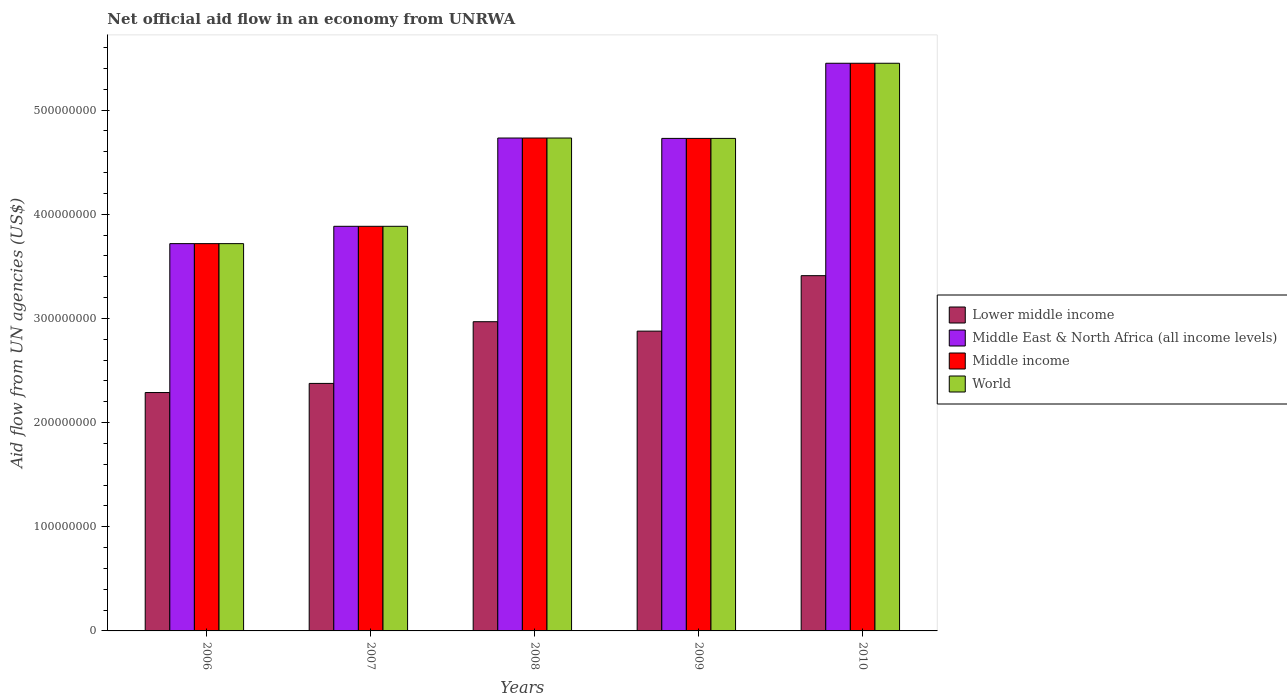Are the number of bars per tick equal to the number of legend labels?
Offer a terse response. Yes. Are the number of bars on each tick of the X-axis equal?
Give a very brief answer. Yes. How many bars are there on the 4th tick from the right?
Make the answer very short. 4. In how many cases, is the number of bars for a given year not equal to the number of legend labels?
Provide a short and direct response. 0. What is the net official aid flow in Lower middle income in 2008?
Provide a short and direct response. 2.97e+08. Across all years, what is the maximum net official aid flow in Middle East & North Africa (all income levels)?
Offer a very short reply. 5.45e+08. Across all years, what is the minimum net official aid flow in Lower middle income?
Give a very brief answer. 2.29e+08. In which year was the net official aid flow in World minimum?
Offer a terse response. 2006. What is the total net official aid flow in Middle East & North Africa (all income levels) in the graph?
Offer a very short reply. 2.25e+09. What is the difference between the net official aid flow in World in 2008 and that in 2010?
Your answer should be compact. -7.18e+07. What is the difference between the net official aid flow in Middle East & North Africa (all income levels) in 2008 and the net official aid flow in World in 2006?
Offer a terse response. 1.01e+08. What is the average net official aid flow in Middle income per year?
Keep it short and to the point. 4.50e+08. In how many years, is the net official aid flow in Middle East & North Africa (all income levels) greater than 320000000 US$?
Provide a short and direct response. 5. What is the ratio of the net official aid flow in Middle income in 2006 to that in 2007?
Give a very brief answer. 0.96. Is the net official aid flow in World in 2008 less than that in 2010?
Your answer should be compact. Yes. What is the difference between the highest and the second highest net official aid flow in World?
Keep it short and to the point. 7.18e+07. What is the difference between the highest and the lowest net official aid flow in Lower middle income?
Your response must be concise. 1.12e+08. Is the sum of the net official aid flow in World in 2008 and 2009 greater than the maximum net official aid flow in Middle East & North Africa (all income levels) across all years?
Give a very brief answer. Yes. Is it the case that in every year, the sum of the net official aid flow in Lower middle income and net official aid flow in Middle East & North Africa (all income levels) is greater than the sum of net official aid flow in Middle income and net official aid flow in World?
Offer a very short reply. No. What does the 2nd bar from the right in 2010 represents?
Offer a very short reply. Middle income. Is it the case that in every year, the sum of the net official aid flow in Middle East & North Africa (all income levels) and net official aid flow in World is greater than the net official aid flow in Middle income?
Offer a very short reply. Yes. How many bars are there?
Keep it short and to the point. 20. Are all the bars in the graph horizontal?
Provide a short and direct response. No. How many years are there in the graph?
Offer a terse response. 5. What is the difference between two consecutive major ticks on the Y-axis?
Your answer should be very brief. 1.00e+08. Are the values on the major ticks of Y-axis written in scientific E-notation?
Keep it short and to the point. No. Where does the legend appear in the graph?
Provide a succinct answer. Center right. How are the legend labels stacked?
Ensure brevity in your answer.  Vertical. What is the title of the graph?
Give a very brief answer. Net official aid flow in an economy from UNRWA. What is the label or title of the X-axis?
Give a very brief answer. Years. What is the label or title of the Y-axis?
Your answer should be compact. Aid flow from UN agencies (US$). What is the Aid flow from UN agencies (US$) in Lower middle income in 2006?
Offer a terse response. 2.29e+08. What is the Aid flow from UN agencies (US$) in Middle East & North Africa (all income levels) in 2006?
Provide a succinct answer. 3.72e+08. What is the Aid flow from UN agencies (US$) in Middle income in 2006?
Your answer should be compact. 3.72e+08. What is the Aid flow from UN agencies (US$) in World in 2006?
Give a very brief answer. 3.72e+08. What is the Aid flow from UN agencies (US$) of Lower middle income in 2007?
Offer a terse response. 2.38e+08. What is the Aid flow from UN agencies (US$) of Middle East & North Africa (all income levels) in 2007?
Your response must be concise. 3.88e+08. What is the Aid flow from UN agencies (US$) in Middle income in 2007?
Ensure brevity in your answer.  3.88e+08. What is the Aid flow from UN agencies (US$) in World in 2007?
Keep it short and to the point. 3.88e+08. What is the Aid flow from UN agencies (US$) of Lower middle income in 2008?
Keep it short and to the point. 2.97e+08. What is the Aid flow from UN agencies (US$) in Middle East & North Africa (all income levels) in 2008?
Provide a succinct answer. 4.73e+08. What is the Aid flow from UN agencies (US$) of Middle income in 2008?
Your response must be concise. 4.73e+08. What is the Aid flow from UN agencies (US$) in World in 2008?
Offer a terse response. 4.73e+08. What is the Aid flow from UN agencies (US$) in Lower middle income in 2009?
Provide a succinct answer. 2.88e+08. What is the Aid flow from UN agencies (US$) of Middle East & North Africa (all income levels) in 2009?
Ensure brevity in your answer.  4.73e+08. What is the Aid flow from UN agencies (US$) of Middle income in 2009?
Offer a terse response. 4.73e+08. What is the Aid flow from UN agencies (US$) of World in 2009?
Provide a short and direct response. 4.73e+08. What is the Aid flow from UN agencies (US$) in Lower middle income in 2010?
Make the answer very short. 3.41e+08. What is the Aid flow from UN agencies (US$) of Middle East & North Africa (all income levels) in 2010?
Ensure brevity in your answer.  5.45e+08. What is the Aid flow from UN agencies (US$) of Middle income in 2010?
Your answer should be very brief. 5.45e+08. What is the Aid flow from UN agencies (US$) of World in 2010?
Provide a short and direct response. 5.45e+08. Across all years, what is the maximum Aid flow from UN agencies (US$) in Lower middle income?
Provide a succinct answer. 3.41e+08. Across all years, what is the maximum Aid flow from UN agencies (US$) in Middle East & North Africa (all income levels)?
Your response must be concise. 5.45e+08. Across all years, what is the maximum Aid flow from UN agencies (US$) in Middle income?
Provide a succinct answer. 5.45e+08. Across all years, what is the maximum Aid flow from UN agencies (US$) of World?
Provide a succinct answer. 5.45e+08. Across all years, what is the minimum Aid flow from UN agencies (US$) of Lower middle income?
Offer a terse response. 2.29e+08. Across all years, what is the minimum Aid flow from UN agencies (US$) in Middle East & North Africa (all income levels)?
Make the answer very short. 3.72e+08. Across all years, what is the minimum Aid flow from UN agencies (US$) in Middle income?
Make the answer very short. 3.72e+08. Across all years, what is the minimum Aid flow from UN agencies (US$) in World?
Offer a very short reply. 3.72e+08. What is the total Aid flow from UN agencies (US$) in Lower middle income in the graph?
Your answer should be compact. 1.39e+09. What is the total Aid flow from UN agencies (US$) of Middle East & North Africa (all income levels) in the graph?
Ensure brevity in your answer.  2.25e+09. What is the total Aid flow from UN agencies (US$) of Middle income in the graph?
Provide a succinct answer. 2.25e+09. What is the total Aid flow from UN agencies (US$) in World in the graph?
Offer a very short reply. 2.25e+09. What is the difference between the Aid flow from UN agencies (US$) in Lower middle income in 2006 and that in 2007?
Offer a very short reply. -8.77e+06. What is the difference between the Aid flow from UN agencies (US$) of Middle East & North Africa (all income levels) in 2006 and that in 2007?
Provide a short and direct response. -1.66e+07. What is the difference between the Aid flow from UN agencies (US$) of Middle income in 2006 and that in 2007?
Your answer should be compact. -1.66e+07. What is the difference between the Aid flow from UN agencies (US$) of World in 2006 and that in 2007?
Give a very brief answer. -1.66e+07. What is the difference between the Aid flow from UN agencies (US$) of Lower middle income in 2006 and that in 2008?
Provide a short and direct response. -6.80e+07. What is the difference between the Aid flow from UN agencies (US$) in Middle East & North Africa (all income levels) in 2006 and that in 2008?
Your response must be concise. -1.01e+08. What is the difference between the Aid flow from UN agencies (US$) in Middle income in 2006 and that in 2008?
Ensure brevity in your answer.  -1.01e+08. What is the difference between the Aid flow from UN agencies (US$) in World in 2006 and that in 2008?
Ensure brevity in your answer.  -1.01e+08. What is the difference between the Aid flow from UN agencies (US$) of Lower middle income in 2006 and that in 2009?
Offer a very short reply. -5.90e+07. What is the difference between the Aid flow from UN agencies (US$) in Middle East & North Africa (all income levels) in 2006 and that in 2009?
Offer a very short reply. -1.01e+08. What is the difference between the Aid flow from UN agencies (US$) of Middle income in 2006 and that in 2009?
Keep it short and to the point. -1.01e+08. What is the difference between the Aid flow from UN agencies (US$) of World in 2006 and that in 2009?
Offer a very short reply. -1.01e+08. What is the difference between the Aid flow from UN agencies (US$) in Lower middle income in 2006 and that in 2010?
Give a very brief answer. -1.12e+08. What is the difference between the Aid flow from UN agencies (US$) in Middle East & North Africa (all income levels) in 2006 and that in 2010?
Make the answer very short. -1.73e+08. What is the difference between the Aid flow from UN agencies (US$) of Middle income in 2006 and that in 2010?
Your response must be concise. -1.73e+08. What is the difference between the Aid flow from UN agencies (US$) of World in 2006 and that in 2010?
Your answer should be very brief. -1.73e+08. What is the difference between the Aid flow from UN agencies (US$) in Lower middle income in 2007 and that in 2008?
Your answer should be very brief. -5.92e+07. What is the difference between the Aid flow from UN agencies (US$) of Middle East & North Africa (all income levels) in 2007 and that in 2008?
Your response must be concise. -8.48e+07. What is the difference between the Aid flow from UN agencies (US$) in Middle income in 2007 and that in 2008?
Your answer should be very brief. -8.48e+07. What is the difference between the Aid flow from UN agencies (US$) in World in 2007 and that in 2008?
Offer a very short reply. -8.48e+07. What is the difference between the Aid flow from UN agencies (US$) of Lower middle income in 2007 and that in 2009?
Your answer should be compact. -5.02e+07. What is the difference between the Aid flow from UN agencies (US$) in Middle East & North Africa (all income levels) in 2007 and that in 2009?
Your answer should be compact. -8.44e+07. What is the difference between the Aid flow from UN agencies (US$) in Middle income in 2007 and that in 2009?
Ensure brevity in your answer.  -8.44e+07. What is the difference between the Aid flow from UN agencies (US$) of World in 2007 and that in 2009?
Your response must be concise. -8.44e+07. What is the difference between the Aid flow from UN agencies (US$) in Lower middle income in 2007 and that in 2010?
Give a very brief answer. -1.03e+08. What is the difference between the Aid flow from UN agencies (US$) of Middle East & North Africa (all income levels) in 2007 and that in 2010?
Offer a terse response. -1.57e+08. What is the difference between the Aid flow from UN agencies (US$) of Middle income in 2007 and that in 2010?
Your answer should be compact. -1.57e+08. What is the difference between the Aid flow from UN agencies (US$) in World in 2007 and that in 2010?
Ensure brevity in your answer.  -1.57e+08. What is the difference between the Aid flow from UN agencies (US$) of Lower middle income in 2008 and that in 2009?
Provide a succinct answer. 9.05e+06. What is the difference between the Aid flow from UN agencies (US$) in Lower middle income in 2008 and that in 2010?
Your answer should be compact. -4.42e+07. What is the difference between the Aid flow from UN agencies (US$) of Middle East & North Africa (all income levels) in 2008 and that in 2010?
Offer a very short reply. -7.18e+07. What is the difference between the Aid flow from UN agencies (US$) in Middle income in 2008 and that in 2010?
Make the answer very short. -7.18e+07. What is the difference between the Aid flow from UN agencies (US$) in World in 2008 and that in 2010?
Ensure brevity in your answer.  -7.18e+07. What is the difference between the Aid flow from UN agencies (US$) of Lower middle income in 2009 and that in 2010?
Offer a very short reply. -5.33e+07. What is the difference between the Aid flow from UN agencies (US$) of Middle East & North Africa (all income levels) in 2009 and that in 2010?
Your answer should be compact. -7.21e+07. What is the difference between the Aid flow from UN agencies (US$) in Middle income in 2009 and that in 2010?
Ensure brevity in your answer.  -7.21e+07. What is the difference between the Aid flow from UN agencies (US$) in World in 2009 and that in 2010?
Provide a succinct answer. -7.21e+07. What is the difference between the Aid flow from UN agencies (US$) in Lower middle income in 2006 and the Aid flow from UN agencies (US$) in Middle East & North Africa (all income levels) in 2007?
Your answer should be compact. -1.60e+08. What is the difference between the Aid flow from UN agencies (US$) in Lower middle income in 2006 and the Aid flow from UN agencies (US$) in Middle income in 2007?
Your response must be concise. -1.60e+08. What is the difference between the Aid flow from UN agencies (US$) in Lower middle income in 2006 and the Aid flow from UN agencies (US$) in World in 2007?
Ensure brevity in your answer.  -1.60e+08. What is the difference between the Aid flow from UN agencies (US$) of Middle East & North Africa (all income levels) in 2006 and the Aid flow from UN agencies (US$) of Middle income in 2007?
Your answer should be compact. -1.66e+07. What is the difference between the Aid flow from UN agencies (US$) in Middle East & North Africa (all income levels) in 2006 and the Aid flow from UN agencies (US$) in World in 2007?
Your response must be concise. -1.66e+07. What is the difference between the Aid flow from UN agencies (US$) in Middle income in 2006 and the Aid flow from UN agencies (US$) in World in 2007?
Give a very brief answer. -1.66e+07. What is the difference between the Aid flow from UN agencies (US$) of Lower middle income in 2006 and the Aid flow from UN agencies (US$) of Middle East & North Africa (all income levels) in 2008?
Give a very brief answer. -2.44e+08. What is the difference between the Aid flow from UN agencies (US$) in Lower middle income in 2006 and the Aid flow from UN agencies (US$) in Middle income in 2008?
Your answer should be very brief. -2.44e+08. What is the difference between the Aid flow from UN agencies (US$) in Lower middle income in 2006 and the Aid flow from UN agencies (US$) in World in 2008?
Your response must be concise. -2.44e+08. What is the difference between the Aid flow from UN agencies (US$) of Middle East & North Africa (all income levels) in 2006 and the Aid flow from UN agencies (US$) of Middle income in 2008?
Provide a succinct answer. -1.01e+08. What is the difference between the Aid flow from UN agencies (US$) of Middle East & North Africa (all income levels) in 2006 and the Aid flow from UN agencies (US$) of World in 2008?
Keep it short and to the point. -1.01e+08. What is the difference between the Aid flow from UN agencies (US$) in Middle income in 2006 and the Aid flow from UN agencies (US$) in World in 2008?
Make the answer very short. -1.01e+08. What is the difference between the Aid flow from UN agencies (US$) in Lower middle income in 2006 and the Aid flow from UN agencies (US$) in Middle East & North Africa (all income levels) in 2009?
Keep it short and to the point. -2.44e+08. What is the difference between the Aid flow from UN agencies (US$) of Lower middle income in 2006 and the Aid flow from UN agencies (US$) of Middle income in 2009?
Give a very brief answer. -2.44e+08. What is the difference between the Aid flow from UN agencies (US$) of Lower middle income in 2006 and the Aid flow from UN agencies (US$) of World in 2009?
Offer a very short reply. -2.44e+08. What is the difference between the Aid flow from UN agencies (US$) of Middle East & North Africa (all income levels) in 2006 and the Aid flow from UN agencies (US$) of Middle income in 2009?
Your answer should be very brief. -1.01e+08. What is the difference between the Aid flow from UN agencies (US$) in Middle East & North Africa (all income levels) in 2006 and the Aid flow from UN agencies (US$) in World in 2009?
Offer a very short reply. -1.01e+08. What is the difference between the Aid flow from UN agencies (US$) in Middle income in 2006 and the Aid flow from UN agencies (US$) in World in 2009?
Keep it short and to the point. -1.01e+08. What is the difference between the Aid flow from UN agencies (US$) of Lower middle income in 2006 and the Aid flow from UN agencies (US$) of Middle East & North Africa (all income levels) in 2010?
Provide a succinct answer. -3.16e+08. What is the difference between the Aid flow from UN agencies (US$) in Lower middle income in 2006 and the Aid flow from UN agencies (US$) in Middle income in 2010?
Keep it short and to the point. -3.16e+08. What is the difference between the Aid flow from UN agencies (US$) in Lower middle income in 2006 and the Aid flow from UN agencies (US$) in World in 2010?
Offer a terse response. -3.16e+08. What is the difference between the Aid flow from UN agencies (US$) in Middle East & North Africa (all income levels) in 2006 and the Aid flow from UN agencies (US$) in Middle income in 2010?
Make the answer very short. -1.73e+08. What is the difference between the Aid flow from UN agencies (US$) of Middle East & North Africa (all income levels) in 2006 and the Aid flow from UN agencies (US$) of World in 2010?
Keep it short and to the point. -1.73e+08. What is the difference between the Aid flow from UN agencies (US$) of Middle income in 2006 and the Aid flow from UN agencies (US$) of World in 2010?
Ensure brevity in your answer.  -1.73e+08. What is the difference between the Aid flow from UN agencies (US$) of Lower middle income in 2007 and the Aid flow from UN agencies (US$) of Middle East & North Africa (all income levels) in 2008?
Offer a terse response. -2.36e+08. What is the difference between the Aid flow from UN agencies (US$) of Lower middle income in 2007 and the Aid flow from UN agencies (US$) of Middle income in 2008?
Keep it short and to the point. -2.36e+08. What is the difference between the Aid flow from UN agencies (US$) of Lower middle income in 2007 and the Aid flow from UN agencies (US$) of World in 2008?
Offer a very short reply. -2.36e+08. What is the difference between the Aid flow from UN agencies (US$) in Middle East & North Africa (all income levels) in 2007 and the Aid flow from UN agencies (US$) in Middle income in 2008?
Provide a succinct answer. -8.48e+07. What is the difference between the Aid flow from UN agencies (US$) of Middle East & North Africa (all income levels) in 2007 and the Aid flow from UN agencies (US$) of World in 2008?
Offer a very short reply. -8.48e+07. What is the difference between the Aid flow from UN agencies (US$) of Middle income in 2007 and the Aid flow from UN agencies (US$) of World in 2008?
Make the answer very short. -8.48e+07. What is the difference between the Aid flow from UN agencies (US$) in Lower middle income in 2007 and the Aid flow from UN agencies (US$) in Middle East & North Africa (all income levels) in 2009?
Offer a very short reply. -2.35e+08. What is the difference between the Aid flow from UN agencies (US$) in Lower middle income in 2007 and the Aid flow from UN agencies (US$) in Middle income in 2009?
Keep it short and to the point. -2.35e+08. What is the difference between the Aid flow from UN agencies (US$) of Lower middle income in 2007 and the Aid flow from UN agencies (US$) of World in 2009?
Provide a short and direct response. -2.35e+08. What is the difference between the Aid flow from UN agencies (US$) in Middle East & North Africa (all income levels) in 2007 and the Aid flow from UN agencies (US$) in Middle income in 2009?
Offer a very short reply. -8.44e+07. What is the difference between the Aid flow from UN agencies (US$) of Middle East & North Africa (all income levels) in 2007 and the Aid flow from UN agencies (US$) of World in 2009?
Offer a terse response. -8.44e+07. What is the difference between the Aid flow from UN agencies (US$) of Middle income in 2007 and the Aid flow from UN agencies (US$) of World in 2009?
Provide a succinct answer. -8.44e+07. What is the difference between the Aid flow from UN agencies (US$) of Lower middle income in 2007 and the Aid flow from UN agencies (US$) of Middle East & North Africa (all income levels) in 2010?
Offer a very short reply. -3.07e+08. What is the difference between the Aid flow from UN agencies (US$) of Lower middle income in 2007 and the Aid flow from UN agencies (US$) of Middle income in 2010?
Provide a succinct answer. -3.07e+08. What is the difference between the Aid flow from UN agencies (US$) of Lower middle income in 2007 and the Aid flow from UN agencies (US$) of World in 2010?
Ensure brevity in your answer.  -3.07e+08. What is the difference between the Aid flow from UN agencies (US$) in Middle East & North Africa (all income levels) in 2007 and the Aid flow from UN agencies (US$) in Middle income in 2010?
Give a very brief answer. -1.57e+08. What is the difference between the Aid flow from UN agencies (US$) of Middle East & North Africa (all income levels) in 2007 and the Aid flow from UN agencies (US$) of World in 2010?
Keep it short and to the point. -1.57e+08. What is the difference between the Aid flow from UN agencies (US$) in Middle income in 2007 and the Aid flow from UN agencies (US$) in World in 2010?
Provide a short and direct response. -1.57e+08. What is the difference between the Aid flow from UN agencies (US$) in Lower middle income in 2008 and the Aid flow from UN agencies (US$) in Middle East & North Africa (all income levels) in 2009?
Make the answer very short. -1.76e+08. What is the difference between the Aid flow from UN agencies (US$) in Lower middle income in 2008 and the Aid flow from UN agencies (US$) in Middle income in 2009?
Keep it short and to the point. -1.76e+08. What is the difference between the Aid flow from UN agencies (US$) in Lower middle income in 2008 and the Aid flow from UN agencies (US$) in World in 2009?
Your answer should be very brief. -1.76e+08. What is the difference between the Aid flow from UN agencies (US$) in Middle East & North Africa (all income levels) in 2008 and the Aid flow from UN agencies (US$) in Middle income in 2009?
Your response must be concise. 3.60e+05. What is the difference between the Aid flow from UN agencies (US$) in Lower middle income in 2008 and the Aid flow from UN agencies (US$) in Middle East & North Africa (all income levels) in 2010?
Your response must be concise. -2.48e+08. What is the difference between the Aid flow from UN agencies (US$) in Lower middle income in 2008 and the Aid flow from UN agencies (US$) in Middle income in 2010?
Ensure brevity in your answer.  -2.48e+08. What is the difference between the Aid flow from UN agencies (US$) of Lower middle income in 2008 and the Aid flow from UN agencies (US$) of World in 2010?
Give a very brief answer. -2.48e+08. What is the difference between the Aid flow from UN agencies (US$) of Middle East & North Africa (all income levels) in 2008 and the Aid flow from UN agencies (US$) of Middle income in 2010?
Give a very brief answer. -7.18e+07. What is the difference between the Aid flow from UN agencies (US$) in Middle East & North Africa (all income levels) in 2008 and the Aid flow from UN agencies (US$) in World in 2010?
Give a very brief answer. -7.18e+07. What is the difference between the Aid flow from UN agencies (US$) of Middle income in 2008 and the Aid flow from UN agencies (US$) of World in 2010?
Offer a terse response. -7.18e+07. What is the difference between the Aid flow from UN agencies (US$) in Lower middle income in 2009 and the Aid flow from UN agencies (US$) in Middle East & North Africa (all income levels) in 2010?
Ensure brevity in your answer.  -2.57e+08. What is the difference between the Aid flow from UN agencies (US$) of Lower middle income in 2009 and the Aid flow from UN agencies (US$) of Middle income in 2010?
Offer a very short reply. -2.57e+08. What is the difference between the Aid flow from UN agencies (US$) of Lower middle income in 2009 and the Aid flow from UN agencies (US$) of World in 2010?
Your answer should be very brief. -2.57e+08. What is the difference between the Aid flow from UN agencies (US$) of Middle East & North Africa (all income levels) in 2009 and the Aid flow from UN agencies (US$) of Middle income in 2010?
Provide a short and direct response. -7.21e+07. What is the difference between the Aid flow from UN agencies (US$) in Middle East & North Africa (all income levels) in 2009 and the Aid flow from UN agencies (US$) in World in 2010?
Keep it short and to the point. -7.21e+07. What is the difference between the Aid flow from UN agencies (US$) of Middle income in 2009 and the Aid flow from UN agencies (US$) of World in 2010?
Provide a short and direct response. -7.21e+07. What is the average Aid flow from UN agencies (US$) in Lower middle income per year?
Make the answer very short. 2.78e+08. What is the average Aid flow from UN agencies (US$) of Middle East & North Africa (all income levels) per year?
Give a very brief answer. 4.50e+08. What is the average Aid flow from UN agencies (US$) in Middle income per year?
Offer a terse response. 4.50e+08. What is the average Aid flow from UN agencies (US$) of World per year?
Provide a short and direct response. 4.50e+08. In the year 2006, what is the difference between the Aid flow from UN agencies (US$) of Lower middle income and Aid flow from UN agencies (US$) of Middle East & North Africa (all income levels)?
Make the answer very short. -1.43e+08. In the year 2006, what is the difference between the Aid flow from UN agencies (US$) in Lower middle income and Aid flow from UN agencies (US$) in Middle income?
Your response must be concise. -1.43e+08. In the year 2006, what is the difference between the Aid flow from UN agencies (US$) of Lower middle income and Aid flow from UN agencies (US$) of World?
Your answer should be compact. -1.43e+08. In the year 2006, what is the difference between the Aid flow from UN agencies (US$) of Middle East & North Africa (all income levels) and Aid flow from UN agencies (US$) of Middle income?
Your answer should be compact. 0. In the year 2007, what is the difference between the Aid flow from UN agencies (US$) in Lower middle income and Aid flow from UN agencies (US$) in Middle East & North Africa (all income levels)?
Provide a succinct answer. -1.51e+08. In the year 2007, what is the difference between the Aid flow from UN agencies (US$) of Lower middle income and Aid flow from UN agencies (US$) of Middle income?
Make the answer very short. -1.51e+08. In the year 2007, what is the difference between the Aid flow from UN agencies (US$) in Lower middle income and Aid flow from UN agencies (US$) in World?
Make the answer very short. -1.51e+08. In the year 2007, what is the difference between the Aid flow from UN agencies (US$) in Middle income and Aid flow from UN agencies (US$) in World?
Your response must be concise. 0. In the year 2008, what is the difference between the Aid flow from UN agencies (US$) in Lower middle income and Aid flow from UN agencies (US$) in Middle East & North Africa (all income levels)?
Keep it short and to the point. -1.76e+08. In the year 2008, what is the difference between the Aid flow from UN agencies (US$) of Lower middle income and Aid flow from UN agencies (US$) of Middle income?
Your response must be concise. -1.76e+08. In the year 2008, what is the difference between the Aid flow from UN agencies (US$) in Lower middle income and Aid flow from UN agencies (US$) in World?
Make the answer very short. -1.76e+08. In the year 2008, what is the difference between the Aid flow from UN agencies (US$) in Middle East & North Africa (all income levels) and Aid flow from UN agencies (US$) in World?
Your response must be concise. 0. In the year 2009, what is the difference between the Aid flow from UN agencies (US$) of Lower middle income and Aid flow from UN agencies (US$) of Middle East & North Africa (all income levels)?
Your answer should be very brief. -1.85e+08. In the year 2009, what is the difference between the Aid flow from UN agencies (US$) of Lower middle income and Aid flow from UN agencies (US$) of Middle income?
Provide a short and direct response. -1.85e+08. In the year 2009, what is the difference between the Aid flow from UN agencies (US$) in Lower middle income and Aid flow from UN agencies (US$) in World?
Your answer should be very brief. -1.85e+08. In the year 2009, what is the difference between the Aid flow from UN agencies (US$) of Middle East & North Africa (all income levels) and Aid flow from UN agencies (US$) of World?
Make the answer very short. 0. In the year 2009, what is the difference between the Aid flow from UN agencies (US$) in Middle income and Aid flow from UN agencies (US$) in World?
Offer a very short reply. 0. In the year 2010, what is the difference between the Aid flow from UN agencies (US$) of Lower middle income and Aid flow from UN agencies (US$) of Middle East & North Africa (all income levels)?
Your response must be concise. -2.04e+08. In the year 2010, what is the difference between the Aid flow from UN agencies (US$) in Lower middle income and Aid flow from UN agencies (US$) in Middle income?
Provide a succinct answer. -2.04e+08. In the year 2010, what is the difference between the Aid flow from UN agencies (US$) in Lower middle income and Aid flow from UN agencies (US$) in World?
Offer a very short reply. -2.04e+08. In the year 2010, what is the difference between the Aid flow from UN agencies (US$) in Middle income and Aid flow from UN agencies (US$) in World?
Make the answer very short. 0. What is the ratio of the Aid flow from UN agencies (US$) in Lower middle income in 2006 to that in 2007?
Ensure brevity in your answer.  0.96. What is the ratio of the Aid flow from UN agencies (US$) of Middle East & North Africa (all income levels) in 2006 to that in 2007?
Make the answer very short. 0.96. What is the ratio of the Aid flow from UN agencies (US$) of Middle income in 2006 to that in 2007?
Keep it short and to the point. 0.96. What is the ratio of the Aid flow from UN agencies (US$) of World in 2006 to that in 2007?
Give a very brief answer. 0.96. What is the ratio of the Aid flow from UN agencies (US$) of Lower middle income in 2006 to that in 2008?
Offer a terse response. 0.77. What is the ratio of the Aid flow from UN agencies (US$) of Middle East & North Africa (all income levels) in 2006 to that in 2008?
Give a very brief answer. 0.79. What is the ratio of the Aid flow from UN agencies (US$) in Middle income in 2006 to that in 2008?
Your answer should be compact. 0.79. What is the ratio of the Aid flow from UN agencies (US$) of World in 2006 to that in 2008?
Provide a succinct answer. 0.79. What is the ratio of the Aid flow from UN agencies (US$) of Lower middle income in 2006 to that in 2009?
Provide a short and direct response. 0.8. What is the ratio of the Aid flow from UN agencies (US$) of Middle East & North Africa (all income levels) in 2006 to that in 2009?
Give a very brief answer. 0.79. What is the ratio of the Aid flow from UN agencies (US$) in Middle income in 2006 to that in 2009?
Keep it short and to the point. 0.79. What is the ratio of the Aid flow from UN agencies (US$) of World in 2006 to that in 2009?
Offer a very short reply. 0.79. What is the ratio of the Aid flow from UN agencies (US$) in Lower middle income in 2006 to that in 2010?
Ensure brevity in your answer.  0.67. What is the ratio of the Aid flow from UN agencies (US$) of Middle East & North Africa (all income levels) in 2006 to that in 2010?
Your answer should be very brief. 0.68. What is the ratio of the Aid flow from UN agencies (US$) in Middle income in 2006 to that in 2010?
Your response must be concise. 0.68. What is the ratio of the Aid flow from UN agencies (US$) in World in 2006 to that in 2010?
Offer a very short reply. 0.68. What is the ratio of the Aid flow from UN agencies (US$) in Lower middle income in 2007 to that in 2008?
Offer a very short reply. 0.8. What is the ratio of the Aid flow from UN agencies (US$) in Middle East & North Africa (all income levels) in 2007 to that in 2008?
Make the answer very short. 0.82. What is the ratio of the Aid flow from UN agencies (US$) of Middle income in 2007 to that in 2008?
Give a very brief answer. 0.82. What is the ratio of the Aid flow from UN agencies (US$) in World in 2007 to that in 2008?
Provide a short and direct response. 0.82. What is the ratio of the Aid flow from UN agencies (US$) in Lower middle income in 2007 to that in 2009?
Offer a terse response. 0.83. What is the ratio of the Aid flow from UN agencies (US$) in Middle East & North Africa (all income levels) in 2007 to that in 2009?
Offer a terse response. 0.82. What is the ratio of the Aid flow from UN agencies (US$) of Middle income in 2007 to that in 2009?
Your response must be concise. 0.82. What is the ratio of the Aid flow from UN agencies (US$) of World in 2007 to that in 2009?
Your response must be concise. 0.82. What is the ratio of the Aid flow from UN agencies (US$) in Lower middle income in 2007 to that in 2010?
Keep it short and to the point. 0.7. What is the ratio of the Aid flow from UN agencies (US$) of Middle East & North Africa (all income levels) in 2007 to that in 2010?
Make the answer very short. 0.71. What is the ratio of the Aid flow from UN agencies (US$) of Middle income in 2007 to that in 2010?
Provide a short and direct response. 0.71. What is the ratio of the Aid flow from UN agencies (US$) in World in 2007 to that in 2010?
Offer a terse response. 0.71. What is the ratio of the Aid flow from UN agencies (US$) of Lower middle income in 2008 to that in 2009?
Your response must be concise. 1.03. What is the ratio of the Aid flow from UN agencies (US$) in Middle income in 2008 to that in 2009?
Offer a terse response. 1. What is the ratio of the Aid flow from UN agencies (US$) in Lower middle income in 2008 to that in 2010?
Offer a terse response. 0.87. What is the ratio of the Aid flow from UN agencies (US$) of Middle East & North Africa (all income levels) in 2008 to that in 2010?
Provide a succinct answer. 0.87. What is the ratio of the Aid flow from UN agencies (US$) in Middle income in 2008 to that in 2010?
Ensure brevity in your answer.  0.87. What is the ratio of the Aid flow from UN agencies (US$) of World in 2008 to that in 2010?
Your answer should be compact. 0.87. What is the ratio of the Aid flow from UN agencies (US$) of Lower middle income in 2009 to that in 2010?
Keep it short and to the point. 0.84. What is the ratio of the Aid flow from UN agencies (US$) of Middle East & North Africa (all income levels) in 2009 to that in 2010?
Offer a very short reply. 0.87. What is the ratio of the Aid flow from UN agencies (US$) in Middle income in 2009 to that in 2010?
Provide a short and direct response. 0.87. What is the ratio of the Aid flow from UN agencies (US$) of World in 2009 to that in 2010?
Offer a very short reply. 0.87. What is the difference between the highest and the second highest Aid flow from UN agencies (US$) of Lower middle income?
Make the answer very short. 4.42e+07. What is the difference between the highest and the second highest Aid flow from UN agencies (US$) of Middle East & North Africa (all income levels)?
Your answer should be very brief. 7.18e+07. What is the difference between the highest and the second highest Aid flow from UN agencies (US$) in Middle income?
Your answer should be very brief. 7.18e+07. What is the difference between the highest and the second highest Aid flow from UN agencies (US$) of World?
Your answer should be very brief. 7.18e+07. What is the difference between the highest and the lowest Aid flow from UN agencies (US$) of Lower middle income?
Your answer should be compact. 1.12e+08. What is the difference between the highest and the lowest Aid flow from UN agencies (US$) in Middle East & North Africa (all income levels)?
Your answer should be compact. 1.73e+08. What is the difference between the highest and the lowest Aid flow from UN agencies (US$) in Middle income?
Ensure brevity in your answer.  1.73e+08. What is the difference between the highest and the lowest Aid flow from UN agencies (US$) of World?
Offer a very short reply. 1.73e+08. 